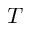Convert formula to latex. <formula><loc_0><loc_0><loc_500><loc_500>T</formula> 